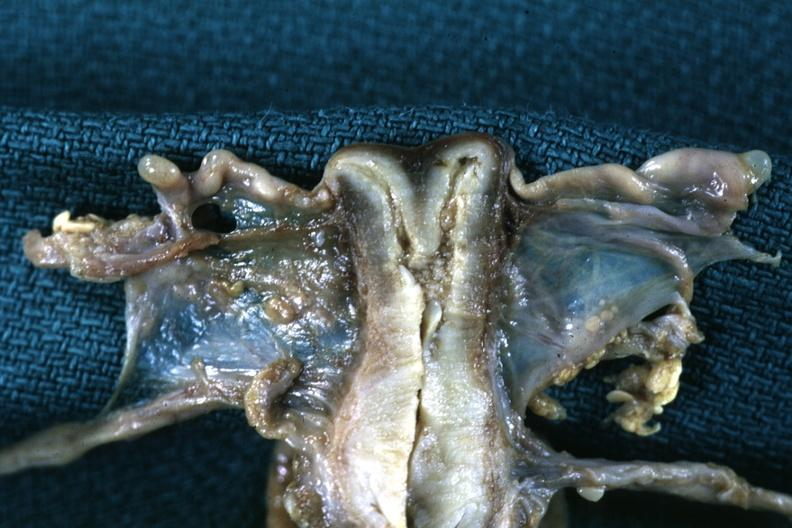what is present?
Answer the question using a single word or phrase. Cervix duplication 